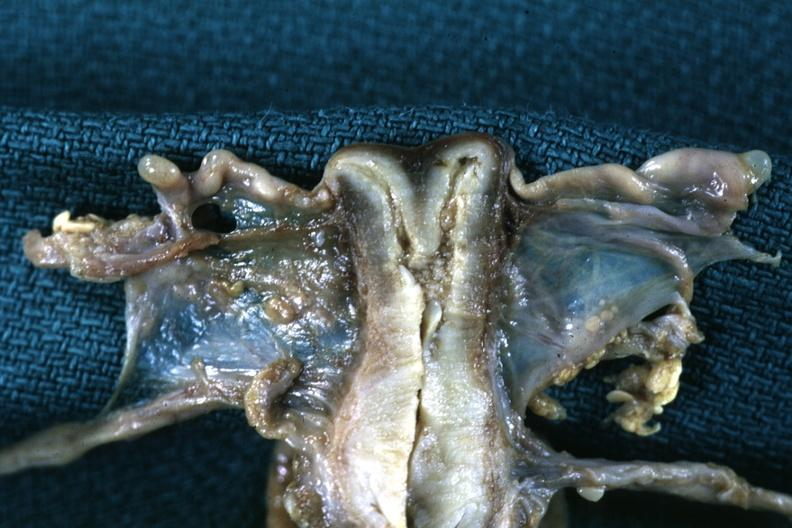what is present?
Answer the question using a single word or phrase. Cervix duplication 